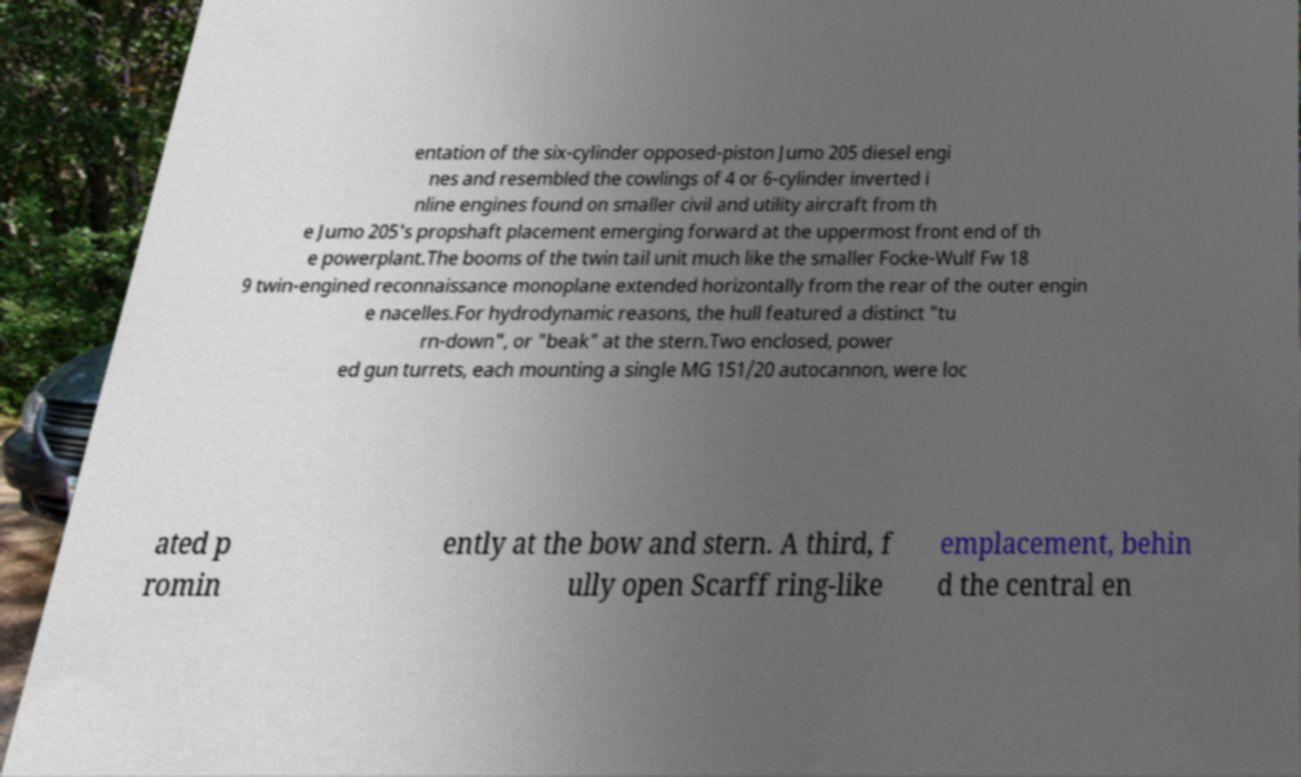Could you assist in decoding the text presented in this image and type it out clearly? entation of the six-cylinder opposed-piston Jumo 205 diesel engi nes and resembled the cowlings of 4 or 6-cylinder inverted i nline engines found on smaller civil and utility aircraft from th e Jumo 205's propshaft placement emerging forward at the uppermost front end of th e powerplant.The booms of the twin tail unit much like the smaller Focke-Wulf Fw 18 9 twin-engined reconnaissance monoplane extended horizontally from the rear of the outer engin e nacelles.For hydrodynamic reasons, the hull featured a distinct "tu rn-down", or "beak" at the stern.Two enclosed, power ed gun turrets, each mounting a single MG 151/20 autocannon, were loc ated p romin ently at the bow and stern. A third, f ully open Scarff ring-like emplacement, behin d the central en 